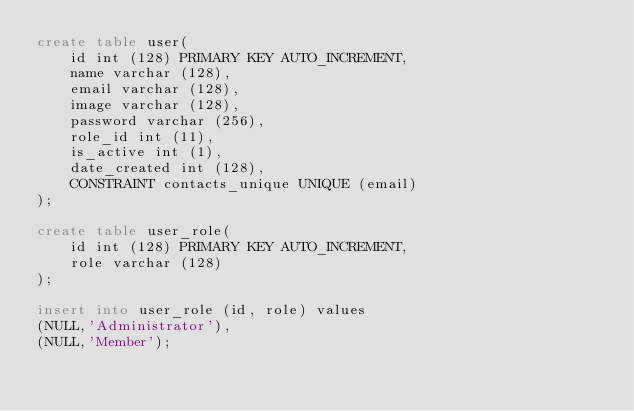Convert code to text. <code><loc_0><loc_0><loc_500><loc_500><_SQL_>create table user(
    id int (128) PRIMARY KEY AUTO_INCREMENT,
    name varchar (128),
    email varchar (128),
    image varchar (128),
    password varchar (256),
    role_id int (11),
    is_active int (1),
    date_created int (128),
    CONSTRAINT contacts_unique UNIQUE (email)
);

create table user_role(
    id int (128) PRIMARY KEY AUTO_INCREMENT,
    role varchar (128)
);

insert into user_role (id, role) values
(NULL,'Administrator'),
(NULL,'Member');</code> 